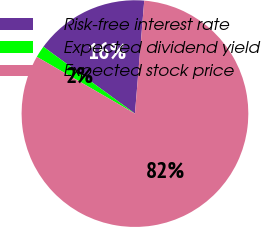Convert chart. <chart><loc_0><loc_0><loc_500><loc_500><pie_chart><fcel>Risk-free interest rate<fcel>Expected dividend yield<fcel>Expected stock price<nl><fcel>16.27%<fcel>1.69%<fcel>82.03%<nl></chart> 